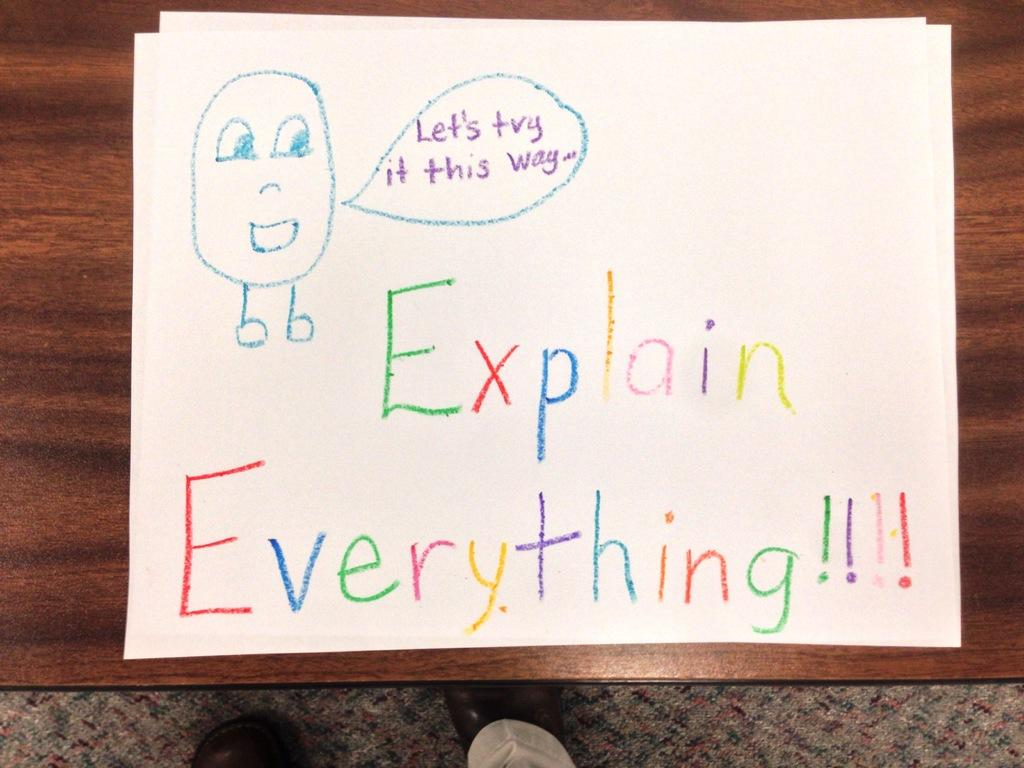Provide a one-sentence caption for the provided image. A drawing made with crayons that says to explain everything. 